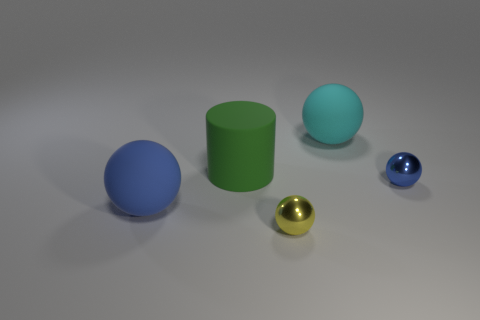Is the cyan object the same shape as the green object?
Your answer should be very brief. No. There is a large thing to the right of the metallic sphere that is in front of the rubber ball in front of the green rubber cylinder; what is its color?
Your answer should be very brief. Cyan. What number of tiny yellow things have the same shape as the big blue thing?
Offer a very short reply. 1. There is a rubber thing that is right of the small yellow metallic object that is on the left side of the small blue metallic ball; what is its size?
Give a very brief answer. Large. Is the size of the cyan rubber sphere the same as the matte cylinder?
Offer a terse response. Yes. There is a metal sphere on the left side of the blue object that is on the right side of the yellow thing; is there a large rubber sphere in front of it?
Give a very brief answer. No. The green object has what size?
Your response must be concise. Large. What number of matte things have the same size as the cyan ball?
Your answer should be very brief. 2. What is the material of the tiny blue object that is the same shape as the small yellow shiny thing?
Give a very brief answer. Metal. The object that is right of the yellow metallic ball and on the left side of the tiny blue ball has what shape?
Provide a short and direct response. Sphere. 